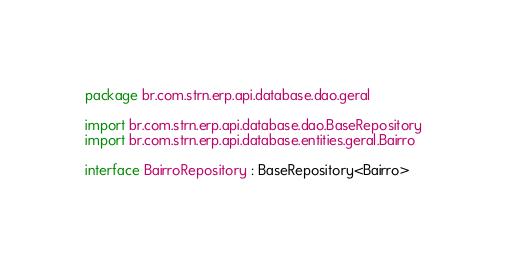<code> <loc_0><loc_0><loc_500><loc_500><_Kotlin_>package br.com.strn.erp.api.database.dao.geral

import br.com.strn.erp.api.database.dao.BaseRepository
import br.com.strn.erp.api.database.entities.geral.Bairro

interface BairroRepository : BaseRepository<Bairro></code> 